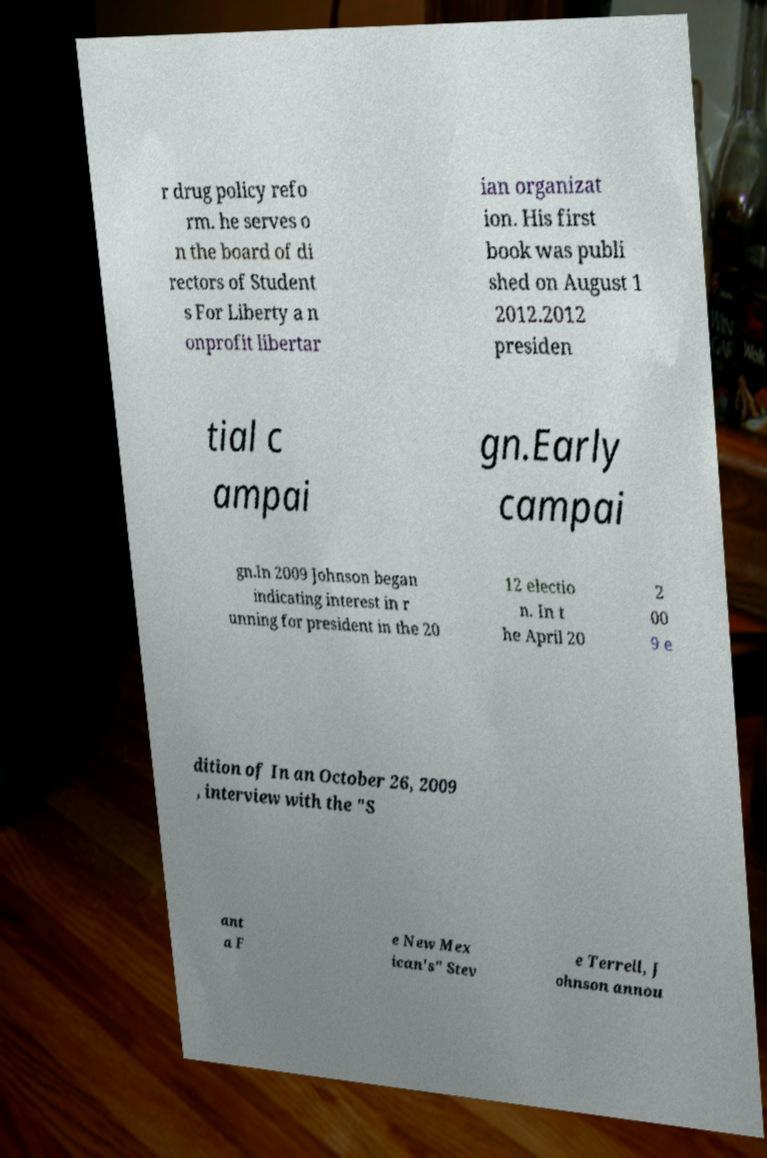I need the written content from this picture converted into text. Can you do that? r drug policy refo rm. he serves o n the board of di rectors of Student s For Liberty a n onprofit libertar ian organizat ion. His first book was publi shed on August 1 2012.2012 presiden tial c ampai gn.Early campai gn.In 2009 Johnson began indicating interest in r unning for president in the 20 12 electio n. In t he April 20 2 00 9 e dition of In an October 26, 2009 , interview with the "S ant a F e New Mex ican's" Stev e Terrell, J ohnson annou 